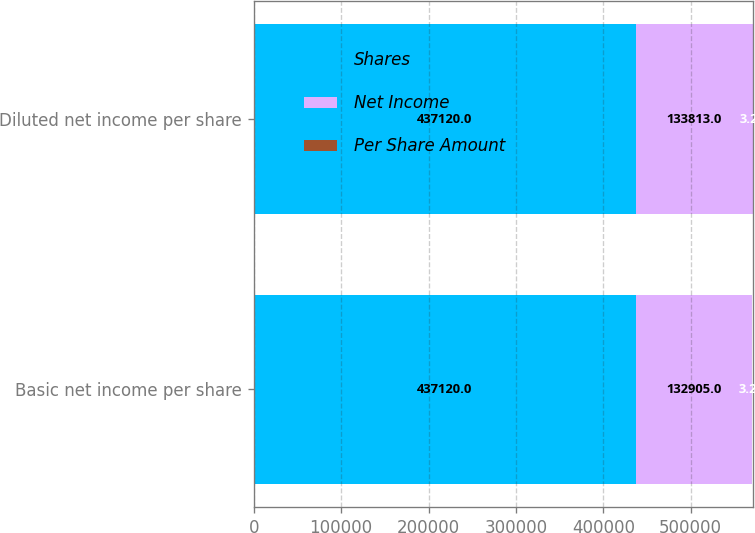<chart> <loc_0><loc_0><loc_500><loc_500><stacked_bar_chart><ecel><fcel>Basic net income per share<fcel>Diluted net income per share<nl><fcel>Shares<fcel>437120<fcel>437120<nl><fcel>Net Income<fcel>132905<fcel>133813<nl><fcel>Per Share Amount<fcel>3.29<fcel>3.27<nl></chart> 